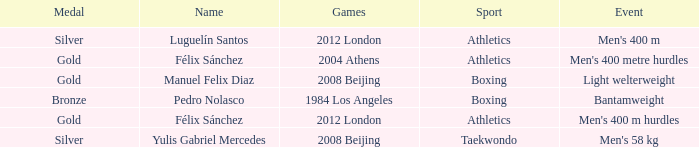Which Games had a Name of manuel felix diaz? 2008 Beijing. 